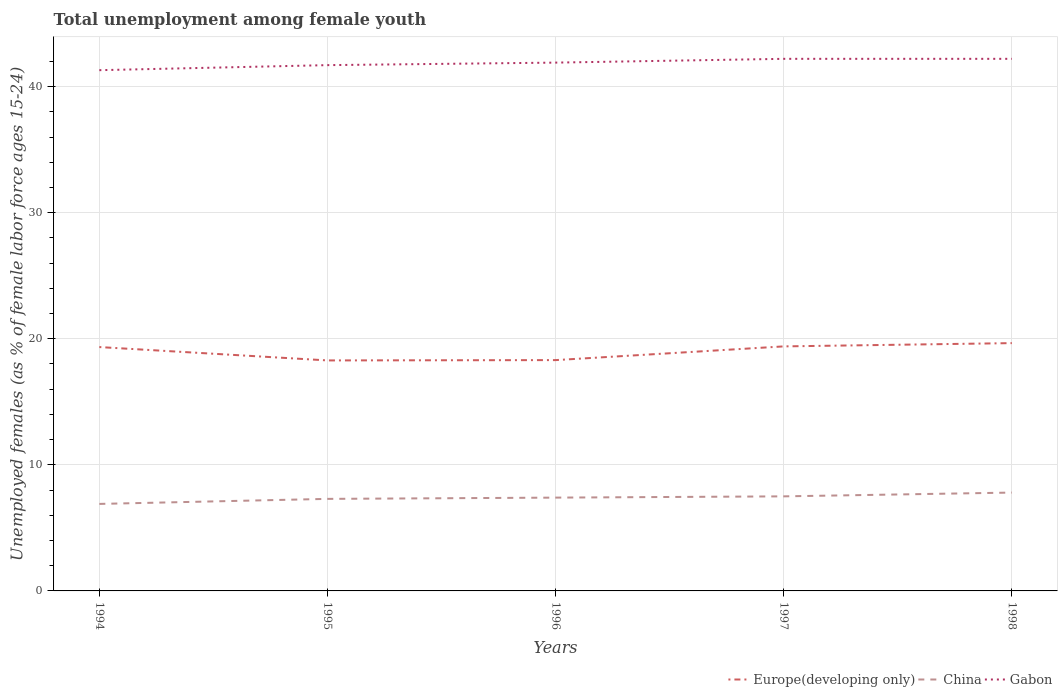Across all years, what is the maximum percentage of unemployed females in in Gabon?
Keep it short and to the point. 41.3. In which year was the percentage of unemployed females in in China maximum?
Offer a very short reply. 1994. What is the total percentage of unemployed females in in China in the graph?
Provide a succinct answer. -0.5. What is the difference between the highest and the second highest percentage of unemployed females in in Europe(developing only)?
Provide a succinct answer. 1.37. What is the difference between the highest and the lowest percentage of unemployed females in in Gabon?
Ensure brevity in your answer.  3. Is the percentage of unemployed females in in China strictly greater than the percentage of unemployed females in in Europe(developing only) over the years?
Provide a short and direct response. Yes. How many lines are there?
Provide a short and direct response. 3. What is the difference between two consecutive major ticks on the Y-axis?
Provide a succinct answer. 10. Does the graph contain any zero values?
Your response must be concise. No. Does the graph contain grids?
Offer a terse response. Yes. Where does the legend appear in the graph?
Your answer should be very brief. Bottom right. How many legend labels are there?
Your response must be concise. 3. How are the legend labels stacked?
Provide a short and direct response. Horizontal. What is the title of the graph?
Offer a very short reply. Total unemployment among female youth. What is the label or title of the Y-axis?
Provide a short and direct response. Unemployed females (as % of female labor force ages 15-24). What is the Unemployed females (as % of female labor force ages 15-24) in Europe(developing only) in 1994?
Your answer should be compact. 19.34. What is the Unemployed females (as % of female labor force ages 15-24) in China in 1994?
Provide a short and direct response. 6.9. What is the Unemployed females (as % of female labor force ages 15-24) in Gabon in 1994?
Offer a very short reply. 41.3. What is the Unemployed females (as % of female labor force ages 15-24) in Europe(developing only) in 1995?
Make the answer very short. 18.28. What is the Unemployed females (as % of female labor force ages 15-24) of China in 1995?
Ensure brevity in your answer.  7.3. What is the Unemployed females (as % of female labor force ages 15-24) in Gabon in 1995?
Your response must be concise. 41.7. What is the Unemployed females (as % of female labor force ages 15-24) of Europe(developing only) in 1996?
Your answer should be compact. 18.31. What is the Unemployed females (as % of female labor force ages 15-24) of China in 1996?
Provide a short and direct response. 7.4. What is the Unemployed females (as % of female labor force ages 15-24) in Gabon in 1996?
Make the answer very short. 41.9. What is the Unemployed females (as % of female labor force ages 15-24) of Europe(developing only) in 1997?
Your answer should be compact. 19.39. What is the Unemployed females (as % of female labor force ages 15-24) in China in 1997?
Your answer should be very brief. 7.5. What is the Unemployed females (as % of female labor force ages 15-24) in Gabon in 1997?
Your response must be concise. 42.2. What is the Unemployed females (as % of female labor force ages 15-24) in Europe(developing only) in 1998?
Keep it short and to the point. 19.65. What is the Unemployed females (as % of female labor force ages 15-24) of China in 1998?
Offer a terse response. 7.8. What is the Unemployed females (as % of female labor force ages 15-24) of Gabon in 1998?
Offer a terse response. 42.2. Across all years, what is the maximum Unemployed females (as % of female labor force ages 15-24) of Europe(developing only)?
Make the answer very short. 19.65. Across all years, what is the maximum Unemployed females (as % of female labor force ages 15-24) in China?
Your answer should be compact. 7.8. Across all years, what is the maximum Unemployed females (as % of female labor force ages 15-24) in Gabon?
Offer a terse response. 42.2. Across all years, what is the minimum Unemployed females (as % of female labor force ages 15-24) in Europe(developing only)?
Your response must be concise. 18.28. Across all years, what is the minimum Unemployed females (as % of female labor force ages 15-24) in China?
Make the answer very short. 6.9. Across all years, what is the minimum Unemployed females (as % of female labor force ages 15-24) in Gabon?
Provide a short and direct response. 41.3. What is the total Unemployed females (as % of female labor force ages 15-24) in Europe(developing only) in the graph?
Your response must be concise. 94.97. What is the total Unemployed females (as % of female labor force ages 15-24) of China in the graph?
Ensure brevity in your answer.  36.9. What is the total Unemployed females (as % of female labor force ages 15-24) of Gabon in the graph?
Offer a terse response. 209.3. What is the difference between the Unemployed females (as % of female labor force ages 15-24) of Europe(developing only) in 1994 and that in 1995?
Provide a succinct answer. 1.06. What is the difference between the Unemployed females (as % of female labor force ages 15-24) of China in 1994 and that in 1995?
Provide a succinct answer. -0.4. What is the difference between the Unemployed females (as % of female labor force ages 15-24) in Europe(developing only) in 1994 and that in 1996?
Provide a succinct answer. 1.03. What is the difference between the Unemployed females (as % of female labor force ages 15-24) of Europe(developing only) in 1994 and that in 1997?
Give a very brief answer. -0.05. What is the difference between the Unemployed females (as % of female labor force ages 15-24) of Europe(developing only) in 1994 and that in 1998?
Your answer should be compact. -0.31. What is the difference between the Unemployed females (as % of female labor force ages 15-24) of Gabon in 1994 and that in 1998?
Give a very brief answer. -0.9. What is the difference between the Unemployed females (as % of female labor force ages 15-24) of Europe(developing only) in 1995 and that in 1996?
Offer a very short reply. -0.03. What is the difference between the Unemployed females (as % of female labor force ages 15-24) of China in 1995 and that in 1996?
Provide a succinct answer. -0.1. What is the difference between the Unemployed females (as % of female labor force ages 15-24) in Europe(developing only) in 1995 and that in 1997?
Provide a succinct answer. -1.11. What is the difference between the Unemployed females (as % of female labor force ages 15-24) in Europe(developing only) in 1995 and that in 1998?
Ensure brevity in your answer.  -1.37. What is the difference between the Unemployed females (as % of female labor force ages 15-24) in Gabon in 1995 and that in 1998?
Keep it short and to the point. -0.5. What is the difference between the Unemployed females (as % of female labor force ages 15-24) of Europe(developing only) in 1996 and that in 1997?
Your answer should be very brief. -1.09. What is the difference between the Unemployed females (as % of female labor force ages 15-24) in China in 1996 and that in 1997?
Offer a very short reply. -0.1. What is the difference between the Unemployed females (as % of female labor force ages 15-24) of Europe(developing only) in 1996 and that in 1998?
Your answer should be very brief. -1.35. What is the difference between the Unemployed females (as % of female labor force ages 15-24) of China in 1996 and that in 1998?
Your response must be concise. -0.4. What is the difference between the Unemployed females (as % of female labor force ages 15-24) in Gabon in 1996 and that in 1998?
Keep it short and to the point. -0.3. What is the difference between the Unemployed females (as % of female labor force ages 15-24) of Europe(developing only) in 1997 and that in 1998?
Provide a short and direct response. -0.26. What is the difference between the Unemployed females (as % of female labor force ages 15-24) in Gabon in 1997 and that in 1998?
Provide a succinct answer. 0. What is the difference between the Unemployed females (as % of female labor force ages 15-24) of Europe(developing only) in 1994 and the Unemployed females (as % of female labor force ages 15-24) of China in 1995?
Provide a short and direct response. 12.04. What is the difference between the Unemployed females (as % of female labor force ages 15-24) in Europe(developing only) in 1994 and the Unemployed females (as % of female labor force ages 15-24) in Gabon in 1995?
Provide a short and direct response. -22.36. What is the difference between the Unemployed females (as % of female labor force ages 15-24) of China in 1994 and the Unemployed females (as % of female labor force ages 15-24) of Gabon in 1995?
Your response must be concise. -34.8. What is the difference between the Unemployed females (as % of female labor force ages 15-24) of Europe(developing only) in 1994 and the Unemployed females (as % of female labor force ages 15-24) of China in 1996?
Your answer should be very brief. 11.94. What is the difference between the Unemployed females (as % of female labor force ages 15-24) in Europe(developing only) in 1994 and the Unemployed females (as % of female labor force ages 15-24) in Gabon in 1996?
Keep it short and to the point. -22.56. What is the difference between the Unemployed females (as % of female labor force ages 15-24) in China in 1994 and the Unemployed females (as % of female labor force ages 15-24) in Gabon in 1996?
Provide a short and direct response. -35. What is the difference between the Unemployed females (as % of female labor force ages 15-24) in Europe(developing only) in 1994 and the Unemployed females (as % of female labor force ages 15-24) in China in 1997?
Provide a short and direct response. 11.84. What is the difference between the Unemployed females (as % of female labor force ages 15-24) in Europe(developing only) in 1994 and the Unemployed females (as % of female labor force ages 15-24) in Gabon in 1997?
Offer a terse response. -22.86. What is the difference between the Unemployed females (as % of female labor force ages 15-24) in China in 1994 and the Unemployed females (as % of female labor force ages 15-24) in Gabon in 1997?
Ensure brevity in your answer.  -35.3. What is the difference between the Unemployed females (as % of female labor force ages 15-24) in Europe(developing only) in 1994 and the Unemployed females (as % of female labor force ages 15-24) in China in 1998?
Provide a short and direct response. 11.54. What is the difference between the Unemployed females (as % of female labor force ages 15-24) of Europe(developing only) in 1994 and the Unemployed females (as % of female labor force ages 15-24) of Gabon in 1998?
Offer a terse response. -22.86. What is the difference between the Unemployed females (as % of female labor force ages 15-24) in China in 1994 and the Unemployed females (as % of female labor force ages 15-24) in Gabon in 1998?
Keep it short and to the point. -35.3. What is the difference between the Unemployed females (as % of female labor force ages 15-24) in Europe(developing only) in 1995 and the Unemployed females (as % of female labor force ages 15-24) in China in 1996?
Give a very brief answer. 10.88. What is the difference between the Unemployed females (as % of female labor force ages 15-24) of Europe(developing only) in 1995 and the Unemployed females (as % of female labor force ages 15-24) of Gabon in 1996?
Keep it short and to the point. -23.62. What is the difference between the Unemployed females (as % of female labor force ages 15-24) in China in 1995 and the Unemployed females (as % of female labor force ages 15-24) in Gabon in 1996?
Make the answer very short. -34.6. What is the difference between the Unemployed females (as % of female labor force ages 15-24) in Europe(developing only) in 1995 and the Unemployed females (as % of female labor force ages 15-24) in China in 1997?
Provide a short and direct response. 10.78. What is the difference between the Unemployed females (as % of female labor force ages 15-24) of Europe(developing only) in 1995 and the Unemployed females (as % of female labor force ages 15-24) of Gabon in 1997?
Keep it short and to the point. -23.92. What is the difference between the Unemployed females (as % of female labor force ages 15-24) in China in 1995 and the Unemployed females (as % of female labor force ages 15-24) in Gabon in 1997?
Your response must be concise. -34.9. What is the difference between the Unemployed females (as % of female labor force ages 15-24) in Europe(developing only) in 1995 and the Unemployed females (as % of female labor force ages 15-24) in China in 1998?
Give a very brief answer. 10.48. What is the difference between the Unemployed females (as % of female labor force ages 15-24) in Europe(developing only) in 1995 and the Unemployed females (as % of female labor force ages 15-24) in Gabon in 1998?
Keep it short and to the point. -23.92. What is the difference between the Unemployed females (as % of female labor force ages 15-24) of China in 1995 and the Unemployed females (as % of female labor force ages 15-24) of Gabon in 1998?
Ensure brevity in your answer.  -34.9. What is the difference between the Unemployed females (as % of female labor force ages 15-24) in Europe(developing only) in 1996 and the Unemployed females (as % of female labor force ages 15-24) in China in 1997?
Keep it short and to the point. 10.81. What is the difference between the Unemployed females (as % of female labor force ages 15-24) in Europe(developing only) in 1996 and the Unemployed females (as % of female labor force ages 15-24) in Gabon in 1997?
Keep it short and to the point. -23.89. What is the difference between the Unemployed females (as % of female labor force ages 15-24) in China in 1996 and the Unemployed females (as % of female labor force ages 15-24) in Gabon in 1997?
Your response must be concise. -34.8. What is the difference between the Unemployed females (as % of female labor force ages 15-24) of Europe(developing only) in 1996 and the Unemployed females (as % of female labor force ages 15-24) of China in 1998?
Offer a terse response. 10.51. What is the difference between the Unemployed females (as % of female labor force ages 15-24) in Europe(developing only) in 1996 and the Unemployed females (as % of female labor force ages 15-24) in Gabon in 1998?
Your answer should be very brief. -23.89. What is the difference between the Unemployed females (as % of female labor force ages 15-24) of China in 1996 and the Unemployed females (as % of female labor force ages 15-24) of Gabon in 1998?
Offer a very short reply. -34.8. What is the difference between the Unemployed females (as % of female labor force ages 15-24) in Europe(developing only) in 1997 and the Unemployed females (as % of female labor force ages 15-24) in China in 1998?
Your response must be concise. 11.59. What is the difference between the Unemployed females (as % of female labor force ages 15-24) of Europe(developing only) in 1997 and the Unemployed females (as % of female labor force ages 15-24) of Gabon in 1998?
Provide a succinct answer. -22.81. What is the difference between the Unemployed females (as % of female labor force ages 15-24) of China in 1997 and the Unemployed females (as % of female labor force ages 15-24) of Gabon in 1998?
Your response must be concise. -34.7. What is the average Unemployed females (as % of female labor force ages 15-24) of Europe(developing only) per year?
Ensure brevity in your answer.  18.99. What is the average Unemployed females (as % of female labor force ages 15-24) of China per year?
Your answer should be compact. 7.38. What is the average Unemployed females (as % of female labor force ages 15-24) of Gabon per year?
Provide a succinct answer. 41.86. In the year 1994, what is the difference between the Unemployed females (as % of female labor force ages 15-24) of Europe(developing only) and Unemployed females (as % of female labor force ages 15-24) of China?
Your answer should be very brief. 12.44. In the year 1994, what is the difference between the Unemployed females (as % of female labor force ages 15-24) of Europe(developing only) and Unemployed females (as % of female labor force ages 15-24) of Gabon?
Offer a very short reply. -21.96. In the year 1994, what is the difference between the Unemployed females (as % of female labor force ages 15-24) of China and Unemployed females (as % of female labor force ages 15-24) of Gabon?
Offer a terse response. -34.4. In the year 1995, what is the difference between the Unemployed females (as % of female labor force ages 15-24) in Europe(developing only) and Unemployed females (as % of female labor force ages 15-24) in China?
Offer a terse response. 10.98. In the year 1995, what is the difference between the Unemployed females (as % of female labor force ages 15-24) of Europe(developing only) and Unemployed females (as % of female labor force ages 15-24) of Gabon?
Offer a very short reply. -23.42. In the year 1995, what is the difference between the Unemployed females (as % of female labor force ages 15-24) in China and Unemployed females (as % of female labor force ages 15-24) in Gabon?
Your answer should be very brief. -34.4. In the year 1996, what is the difference between the Unemployed females (as % of female labor force ages 15-24) of Europe(developing only) and Unemployed females (as % of female labor force ages 15-24) of China?
Provide a succinct answer. 10.91. In the year 1996, what is the difference between the Unemployed females (as % of female labor force ages 15-24) in Europe(developing only) and Unemployed females (as % of female labor force ages 15-24) in Gabon?
Provide a short and direct response. -23.59. In the year 1996, what is the difference between the Unemployed females (as % of female labor force ages 15-24) in China and Unemployed females (as % of female labor force ages 15-24) in Gabon?
Your response must be concise. -34.5. In the year 1997, what is the difference between the Unemployed females (as % of female labor force ages 15-24) in Europe(developing only) and Unemployed females (as % of female labor force ages 15-24) in China?
Ensure brevity in your answer.  11.89. In the year 1997, what is the difference between the Unemployed females (as % of female labor force ages 15-24) in Europe(developing only) and Unemployed females (as % of female labor force ages 15-24) in Gabon?
Provide a succinct answer. -22.81. In the year 1997, what is the difference between the Unemployed females (as % of female labor force ages 15-24) in China and Unemployed females (as % of female labor force ages 15-24) in Gabon?
Offer a terse response. -34.7. In the year 1998, what is the difference between the Unemployed females (as % of female labor force ages 15-24) in Europe(developing only) and Unemployed females (as % of female labor force ages 15-24) in China?
Provide a succinct answer. 11.85. In the year 1998, what is the difference between the Unemployed females (as % of female labor force ages 15-24) of Europe(developing only) and Unemployed females (as % of female labor force ages 15-24) of Gabon?
Offer a very short reply. -22.55. In the year 1998, what is the difference between the Unemployed females (as % of female labor force ages 15-24) of China and Unemployed females (as % of female labor force ages 15-24) of Gabon?
Make the answer very short. -34.4. What is the ratio of the Unemployed females (as % of female labor force ages 15-24) of Europe(developing only) in 1994 to that in 1995?
Provide a short and direct response. 1.06. What is the ratio of the Unemployed females (as % of female labor force ages 15-24) in China in 1994 to that in 1995?
Offer a terse response. 0.95. What is the ratio of the Unemployed females (as % of female labor force ages 15-24) of Europe(developing only) in 1994 to that in 1996?
Your answer should be compact. 1.06. What is the ratio of the Unemployed females (as % of female labor force ages 15-24) of China in 1994 to that in 1996?
Provide a succinct answer. 0.93. What is the ratio of the Unemployed females (as % of female labor force ages 15-24) of Gabon in 1994 to that in 1996?
Give a very brief answer. 0.99. What is the ratio of the Unemployed females (as % of female labor force ages 15-24) in Gabon in 1994 to that in 1997?
Your answer should be compact. 0.98. What is the ratio of the Unemployed females (as % of female labor force ages 15-24) of Europe(developing only) in 1994 to that in 1998?
Offer a very short reply. 0.98. What is the ratio of the Unemployed females (as % of female labor force ages 15-24) of China in 1994 to that in 1998?
Ensure brevity in your answer.  0.88. What is the ratio of the Unemployed females (as % of female labor force ages 15-24) of Gabon in 1994 to that in 1998?
Your answer should be very brief. 0.98. What is the ratio of the Unemployed females (as % of female labor force ages 15-24) in China in 1995 to that in 1996?
Give a very brief answer. 0.99. What is the ratio of the Unemployed females (as % of female labor force ages 15-24) in Europe(developing only) in 1995 to that in 1997?
Offer a terse response. 0.94. What is the ratio of the Unemployed females (as % of female labor force ages 15-24) in China in 1995 to that in 1997?
Ensure brevity in your answer.  0.97. What is the ratio of the Unemployed females (as % of female labor force ages 15-24) in Gabon in 1995 to that in 1997?
Your response must be concise. 0.99. What is the ratio of the Unemployed females (as % of female labor force ages 15-24) of Europe(developing only) in 1995 to that in 1998?
Ensure brevity in your answer.  0.93. What is the ratio of the Unemployed females (as % of female labor force ages 15-24) of China in 1995 to that in 1998?
Make the answer very short. 0.94. What is the ratio of the Unemployed females (as % of female labor force ages 15-24) of Gabon in 1995 to that in 1998?
Your answer should be very brief. 0.99. What is the ratio of the Unemployed females (as % of female labor force ages 15-24) in Europe(developing only) in 1996 to that in 1997?
Give a very brief answer. 0.94. What is the ratio of the Unemployed females (as % of female labor force ages 15-24) in China in 1996 to that in 1997?
Keep it short and to the point. 0.99. What is the ratio of the Unemployed females (as % of female labor force ages 15-24) in Europe(developing only) in 1996 to that in 1998?
Give a very brief answer. 0.93. What is the ratio of the Unemployed females (as % of female labor force ages 15-24) of China in 1996 to that in 1998?
Provide a short and direct response. 0.95. What is the ratio of the Unemployed females (as % of female labor force ages 15-24) of China in 1997 to that in 1998?
Make the answer very short. 0.96. What is the difference between the highest and the second highest Unemployed females (as % of female labor force ages 15-24) of Europe(developing only)?
Your answer should be compact. 0.26. What is the difference between the highest and the second highest Unemployed females (as % of female labor force ages 15-24) in Gabon?
Make the answer very short. 0. What is the difference between the highest and the lowest Unemployed females (as % of female labor force ages 15-24) of Europe(developing only)?
Keep it short and to the point. 1.37. What is the difference between the highest and the lowest Unemployed females (as % of female labor force ages 15-24) of Gabon?
Offer a terse response. 0.9. 